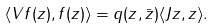Convert formula to latex. <formula><loc_0><loc_0><loc_500><loc_500>\langle V f ( z ) , f ( z ) \rangle = q ( z , \bar { z } ) \langle J z , z \rangle .</formula> 